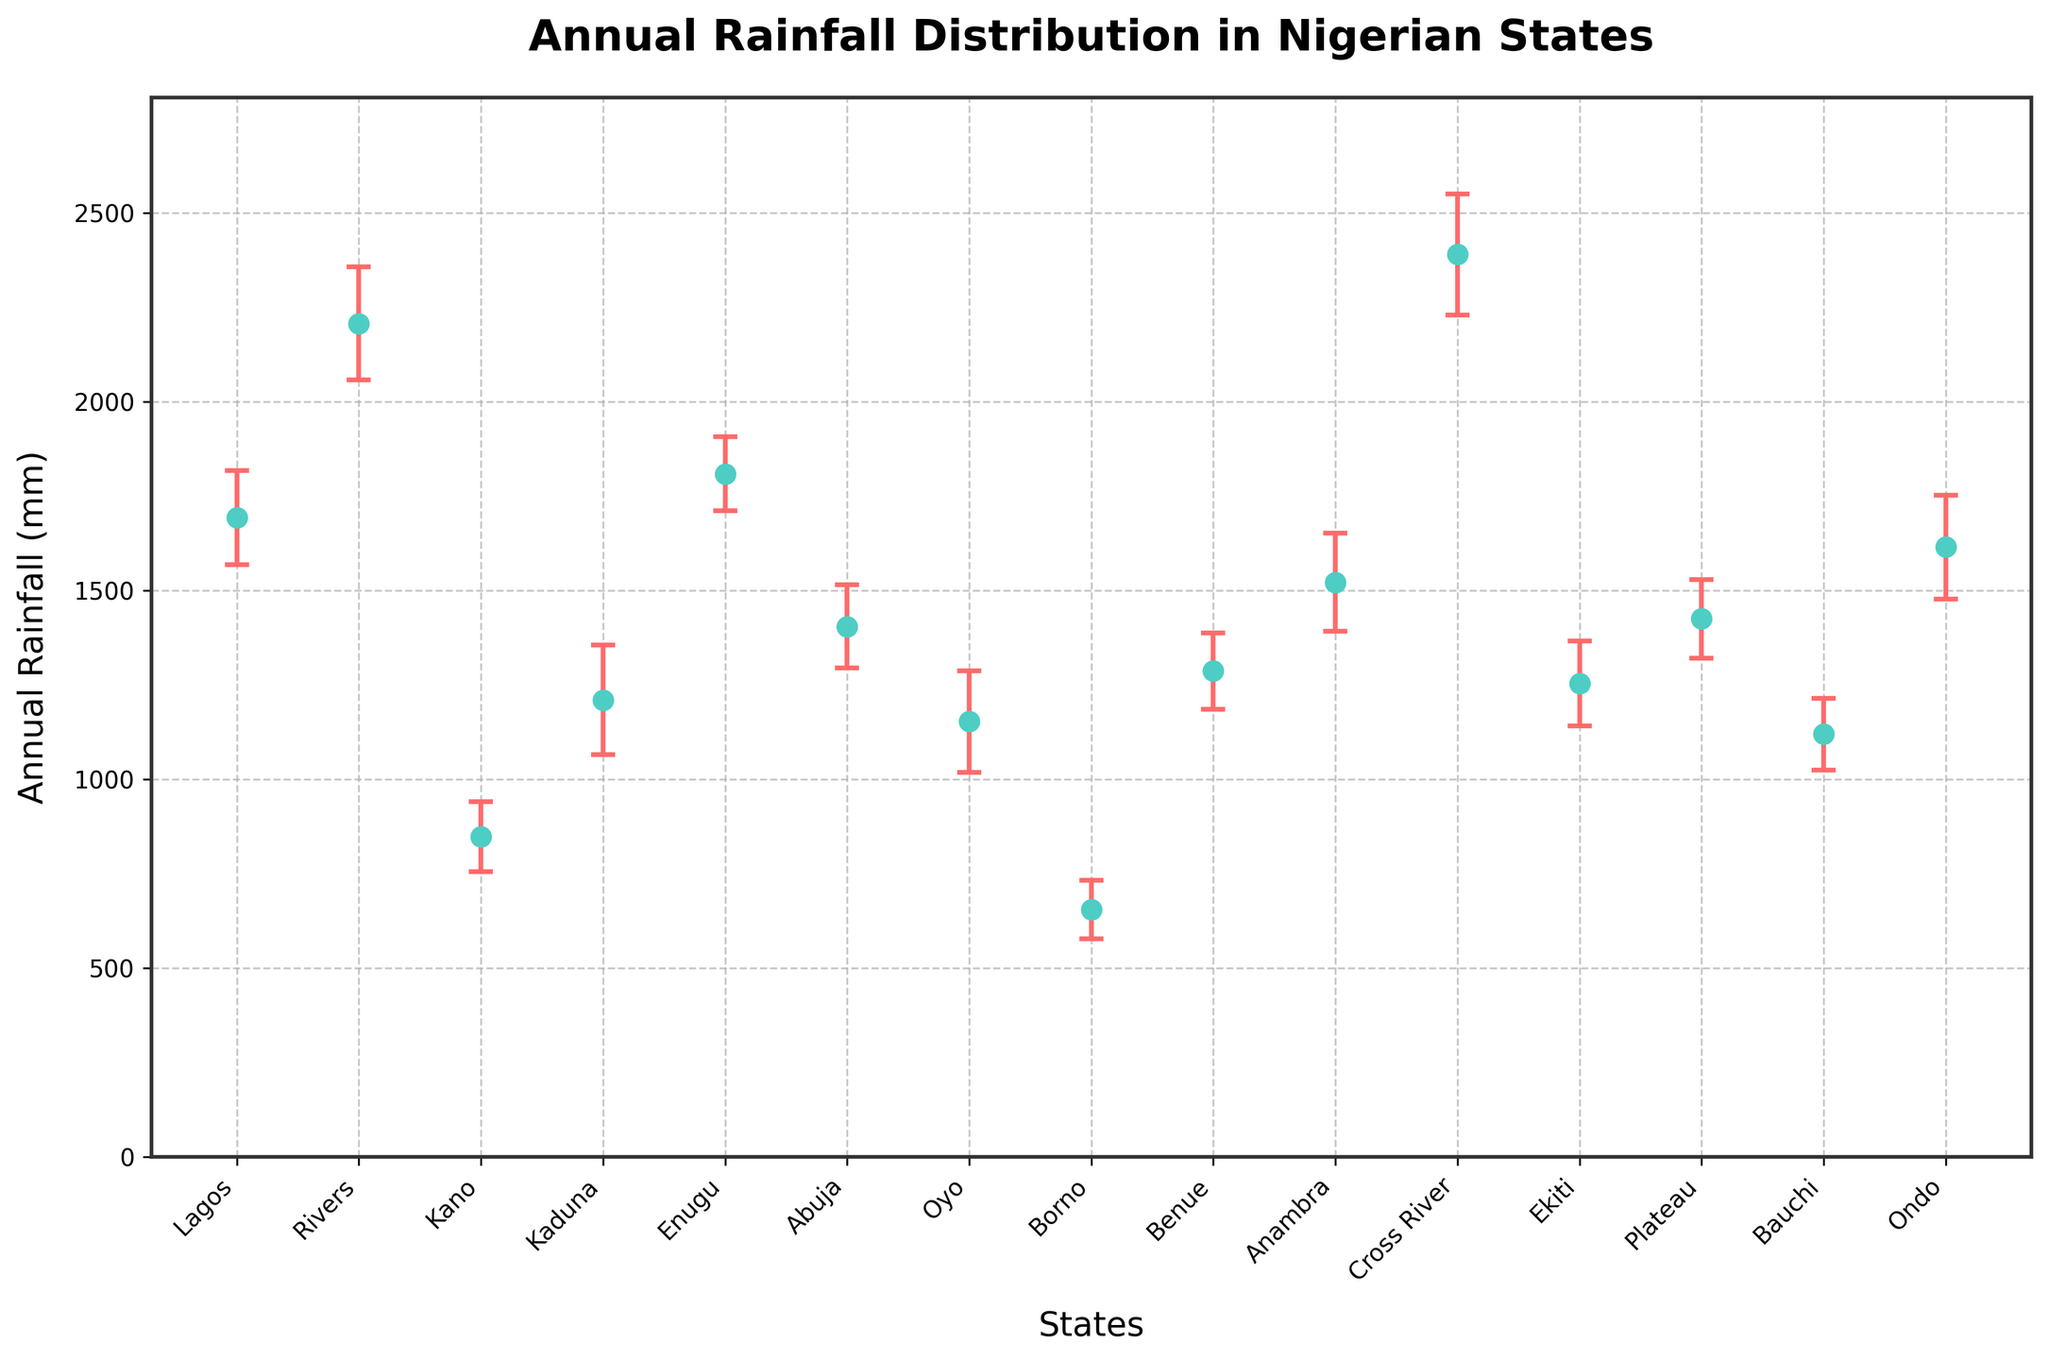what is the title of the plot? The title of the plot is mentioned at the top of the figure. It reads "Annual Rainfall Distribution in Nigerian States", indicating the data it visualizes.
Answer: Annual Rainfall Distribution in Nigerian States how many Nigerian states are represented in the plot? By counting the number of different states listed along the horizontal axis, you can determine the total number of states included. There are 15 Nigerian states represented.
Answer: 15 which state has the highest annual rainfall, and what is its value including the margin of error? The state with the highest annual rainfall is identified by the data point positioned highest on the vertical "Annual Rainfall (mm)" axis. Rivers has the highest annual rainfall at 2207 mm, with a margin of error of 150 mm. Thus, the highest value is 2207 + 150 = 2357 mm.
Answer: Rivers, 2357 mm how does the annual rainfall in Kaduna compare to that in Oyo? To compare the annual rainfall between Kaduna and Oyo, find their values and compare them directly from the plot. Kaduna has an annual rainfall of 1210 mm, while Oyo's is 1153 mm. Therefore, Kaduna receives more annual rainfall than Oyo.
Answer: Kaduna receives more rainfall than Oyo which states have a margin of error greater than 120 mm? Search for the states with margin of error more than 120 mm as shown by the vertical error bars with the corresponding numerical values in the figure. The states are Lagos (124 mm), Rivers (150 mm), Kaduna (145 mm), Oyo (135 mm), Anambra (130 mm), Cross River (160 mm), and Ondo (138 mm).
Answer: Lagos, Rivers, Kaduna, Oyo, Anambra, Cross River, Ondo what is the range of annual rainfall for Enugu including the margin of error? The range of annual rainfall for Enugu can be derived by considering its value and margin of error. Enugu has an annual rainfall of 1809 mm with a margin of error of 98 mm. Therefore, the range is [1809 - 98, 1809 + 98] = [1711 mm, 1907 mm].
Answer: 1711 mm to 1907 mm which state has the smallest margin of error, and what is the value? Identify the state with the shortest error bar on the plot and check the margin of error's value. Borno has the smallest margin of error at 77 mm.
Answer: Borno, 77 mm how does Abuja's annual rainfall with its margin of error compare to the minimum annual rainfall of Borno? Abuja's rainfall is 1405 mm with a margin of error of 110 mm, resulting in a minimum of 1405 - 110 = 1295 mm. Borno's annual rainfall, the minimum in the plot, is 655 mm. Thus, even the minimum rainfall of Abuja (1295 mm) is significantly higher than Borno's maximum.
Answer: Abuja's minimum is still higher than Borno's maximum if you average the annual rainfall of all states excluding their margin of error, what value do you get? To average the annual rainfall, sum the values of all states and divide by the number of states. Sum = 1693 + 2207 + 848 + 1210 + 1809 + 1405 + 1153 + 655 + 1287 + 1522 + 2390 + 1254 + 1425 + 1120 + 1615 = 21493 mm. Average annual rainfall = 21493 / 15 = 1433 mm.
Answer: 1433 mm 